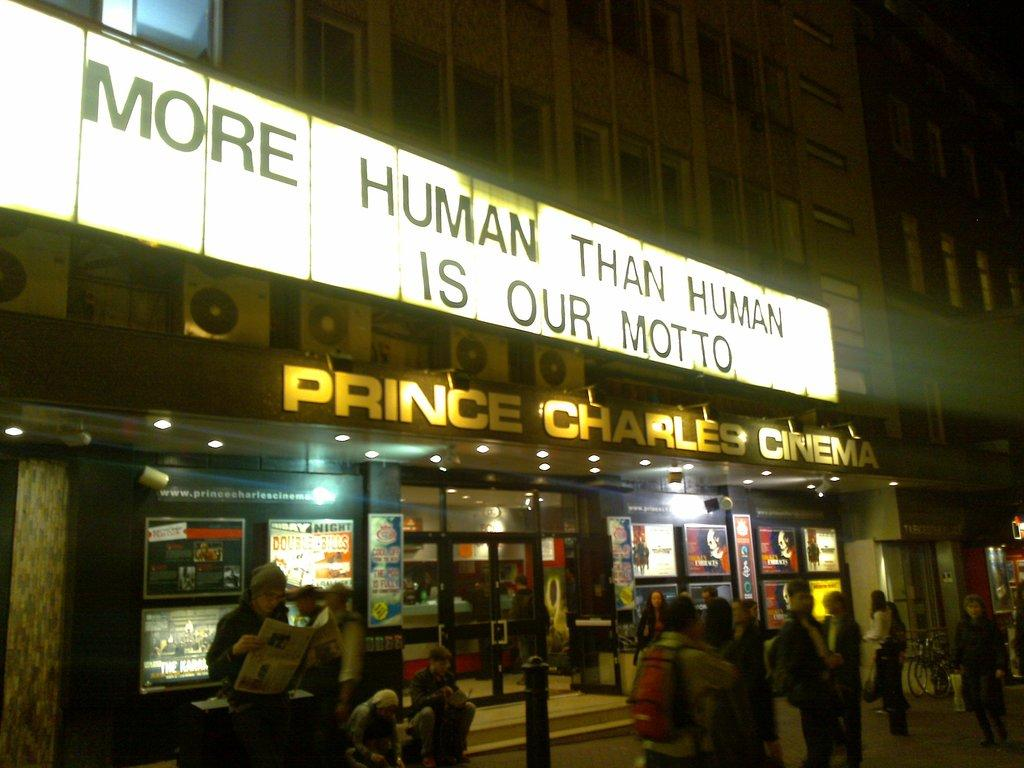Provide a one-sentence caption for the provided image. A cinema that believes in becoming more human than human. 